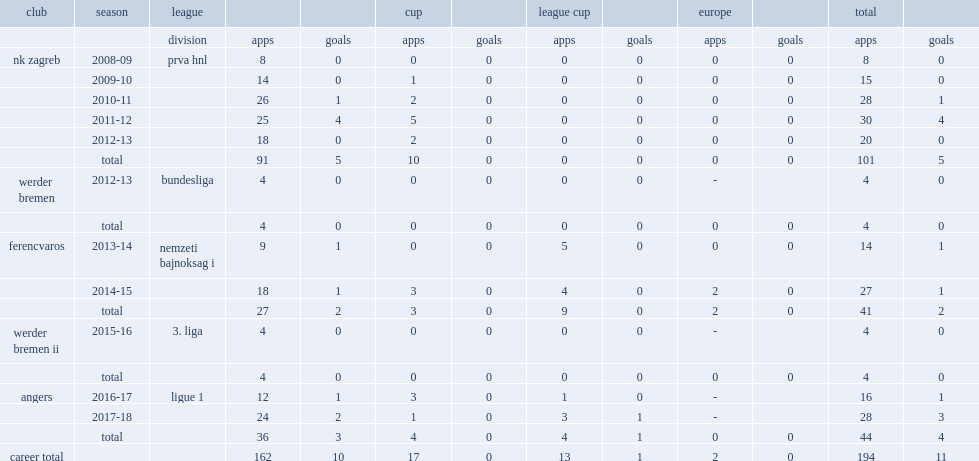Which club did mateo pavlovic play for in 2008-09? Nk zagreb. 